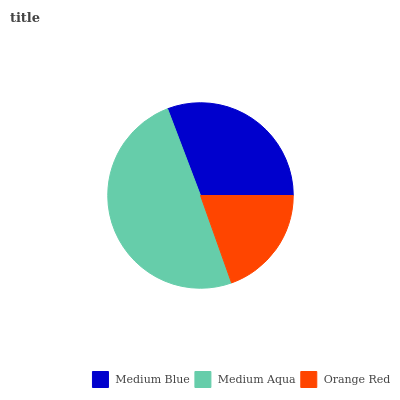Is Orange Red the minimum?
Answer yes or no. Yes. Is Medium Aqua the maximum?
Answer yes or no. Yes. Is Medium Aqua the minimum?
Answer yes or no. No. Is Orange Red the maximum?
Answer yes or no. No. Is Medium Aqua greater than Orange Red?
Answer yes or no. Yes. Is Orange Red less than Medium Aqua?
Answer yes or no. Yes. Is Orange Red greater than Medium Aqua?
Answer yes or no. No. Is Medium Aqua less than Orange Red?
Answer yes or no. No. Is Medium Blue the high median?
Answer yes or no. Yes. Is Medium Blue the low median?
Answer yes or no. Yes. Is Orange Red the high median?
Answer yes or no. No. Is Medium Aqua the low median?
Answer yes or no. No. 